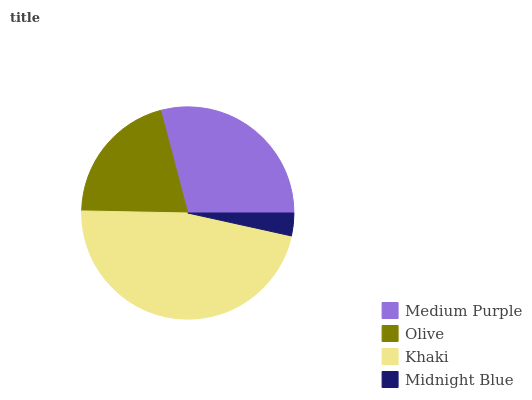Is Midnight Blue the minimum?
Answer yes or no. Yes. Is Khaki the maximum?
Answer yes or no. Yes. Is Olive the minimum?
Answer yes or no. No. Is Olive the maximum?
Answer yes or no. No. Is Medium Purple greater than Olive?
Answer yes or no. Yes. Is Olive less than Medium Purple?
Answer yes or no. Yes. Is Olive greater than Medium Purple?
Answer yes or no. No. Is Medium Purple less than Olive?
Answer yes or no. No. Is Medium Purple the high median?
Answer yes or no. Yes. Is Olive the low median?
Answer yes or no. Yes. Is Olive the high median?
Answer yes or no. No. Is Khaki the low median?
Answer yes or no. No. 